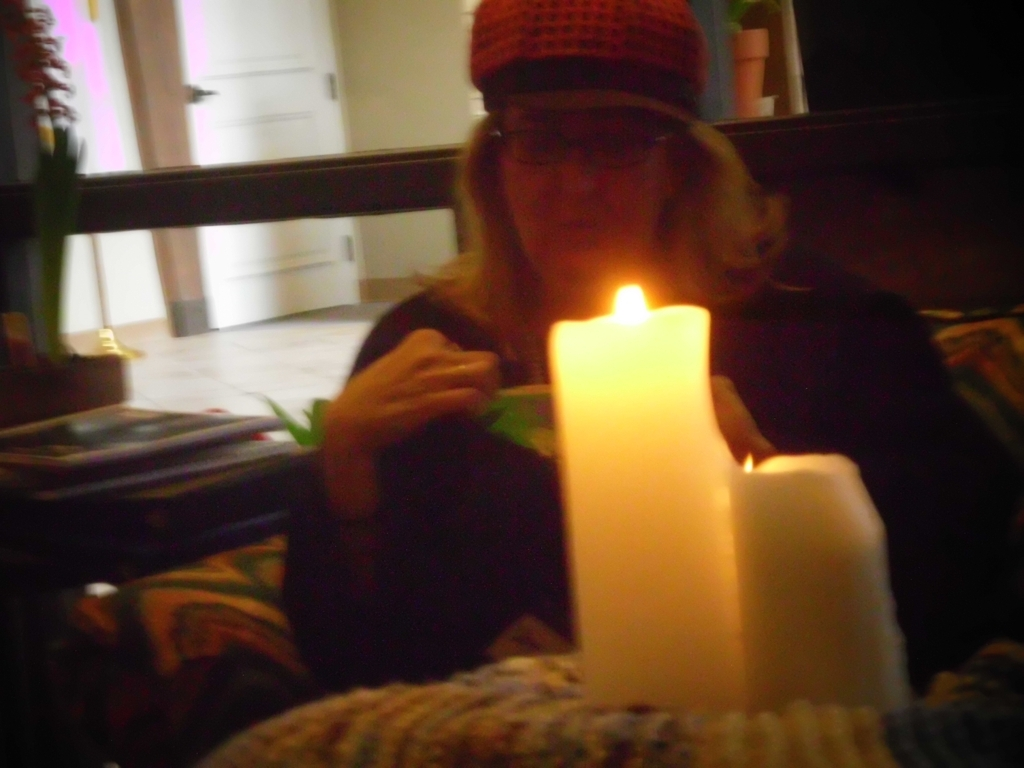Can you describe what the person might be doing or feeling in this image based on their expression and posture? Although the image is somewhat obscured by the dim lighting, the person seems to be engaged in a peaceful, possibly introspective activity. With their head slightly bowed towards the candle's light and holding something that could be a book or a craft, they may be experiencing a moment of contemplation, relaxation, or focused creativity. 